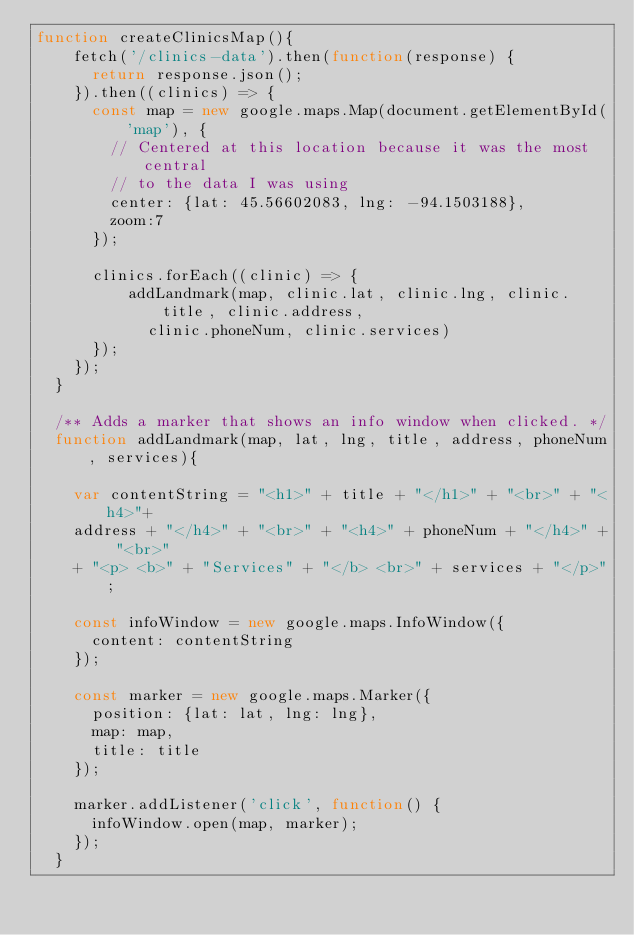<code> <loc_0><loc_0><loc_500><loc_500><_JavaScript_>function createClinicsMap(){
    fetch('/clinics-data').then(function(response) {
      return response.json();
    }).then((clinics) => {
      const map = new google.maps.Map(document.getElementById('map'), {
        // Centered at this location because it was the most central 
        // to the data I was using
        center: {lat: 45.56602083, lng: -94.1503188},
        zoom:7
      });

      clinics.forEach((clinic) => {
          addLandmark(map, clinic.lat, clinic.lng, clinic.title, clinic.address, 
            clinic.phoneNum, clinic.services)
      });
    });
  }

  /** Adds a marker that shows an info window when clicked. */
  function addLandmark(map, lat, lng, title, address, phoneNum, services){

    var contentString = "<h1>" + title + "</h1>" + "<br>" + "<h4>"+ 
    address + "</h4>" + "<br>" + "<h4>" + phoneNum + "</h4>" + "<br>" 
    + "<p> <b>" + "Services" + "</b> <br>" + services + "</p>";

    const infoWindow = new google.maps.InfoWindow({
      content: contentString
    });

    const marker = new google.maps.Marker({
      position: {lat: lat, lng: lng},
      map: map,
      title: title
    });
    
    marker.addListener('click', function() {
      infoWindow.open(map, marker);
    });
  }</code> 